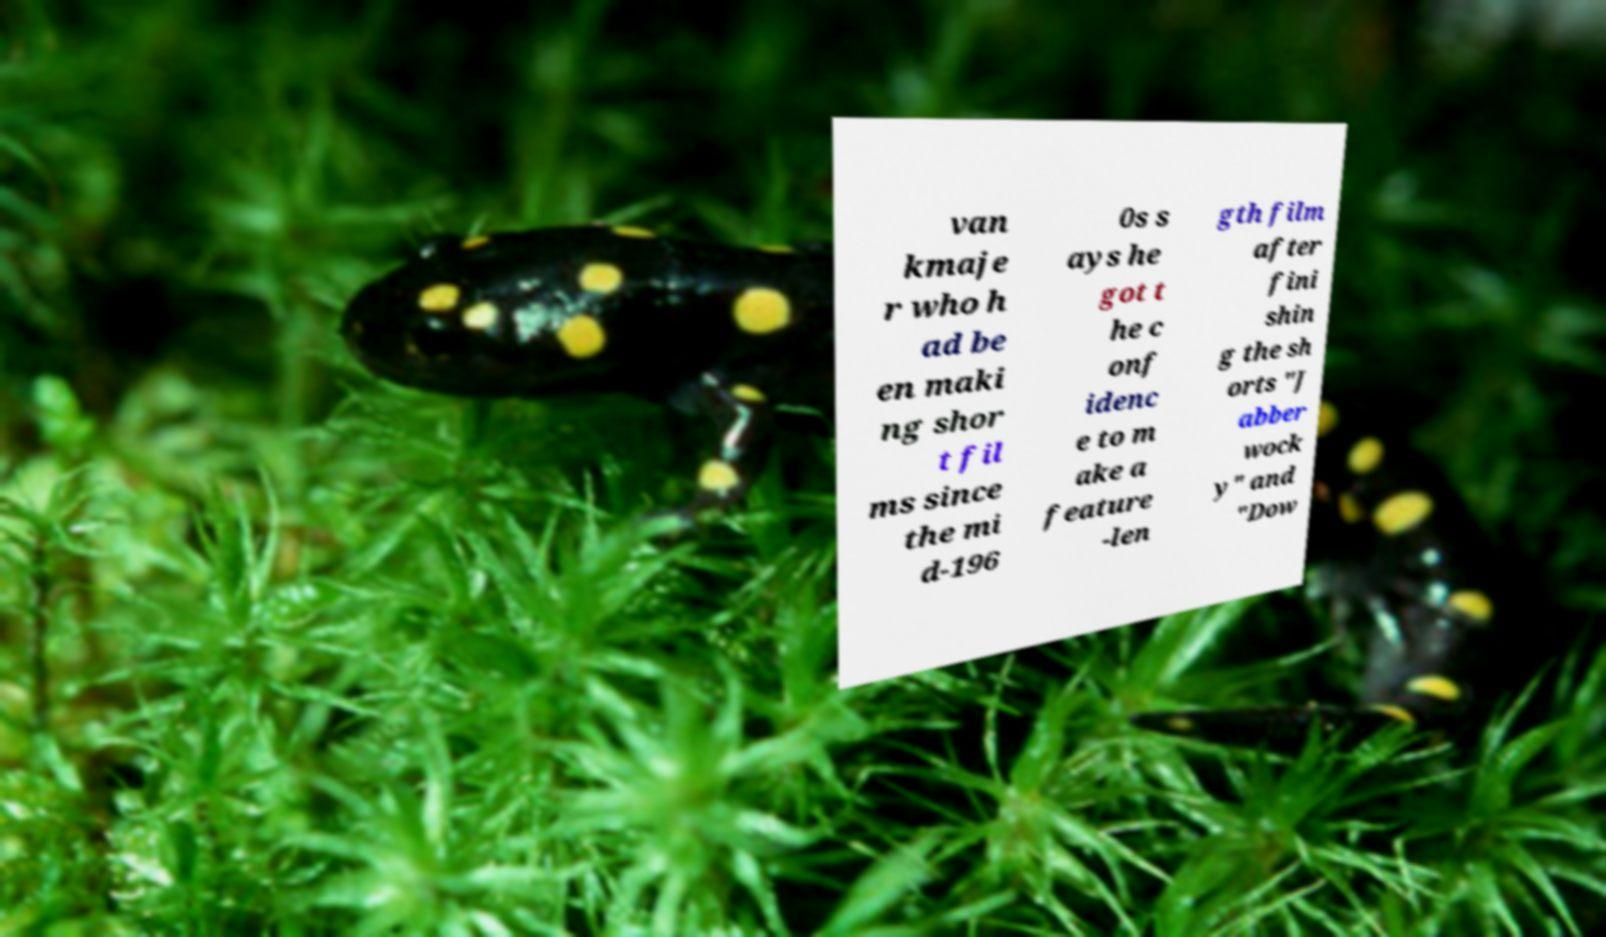Please identify and transcribe the text found in this image. van kmaje r who h ad be en maki ng shor t fil ms since the mi d-196 0s s ays he got t he c onf idenc e to m ake a feature -len gth film after fini shin g the sh orts "J abber wock y" and "Dow 